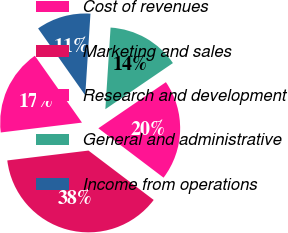Convert chart. <chart><loc_0><loc_0><loc_500><loc_500><pie_chart><fcel>Cost of revenues<fcel>Marketing and sales<fcel>Research and development<fcel>General and administrative<fcel>Income from operations<nl><fcel>17.15%<fcel>37.76%<fcel>19.85%<fcel>14.45%<fcel>10.79%<nl></chart> 